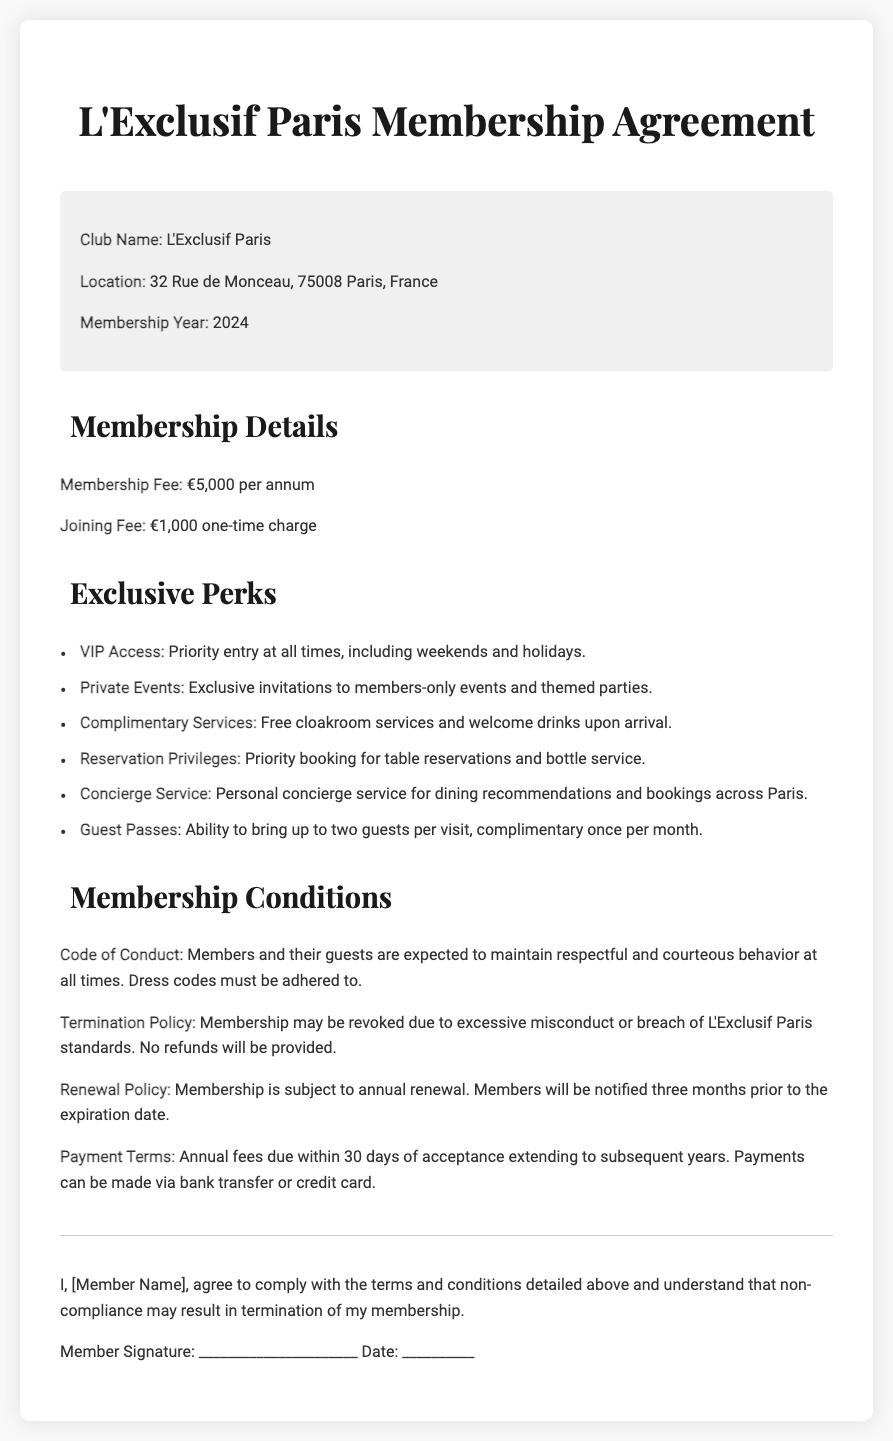What is the club name? The club name is specified in the document under "Club Name."
Answer: L'Exclusif Paris What is the annual membership fee? The annual membership fee is listed under "Membership Fee."
Answer: €5,000 How much is the joining fee? The joining fee is provided in the "Membership Details" section.
Answer: €1,000 Where is the club located? The location is mentioned in the document under "Location."
Answer: 32 Rue de Monceau, 75008 Paris, France What is one of the exclusive perks offered to members? This requires identifying any single perk from the "Exclusive Perks" section.
Answer: VIP Access What is the renewal policy notification period? This information is found in the "Renewal Policy."
Answer: three months What happens if a member breaches the code of conduct? This part concerns the consequences outlined in the "Termination Policy."
Answer: Membership may be revoked How many guests can members bring per visit? This detail is stated in the "Guest Passes" section of the document.
Answer: Two guests What payment methods are accepted for the annual fees? This is found in the "Payment Terms" section of the document.
Answer: bank transfer or credit card 